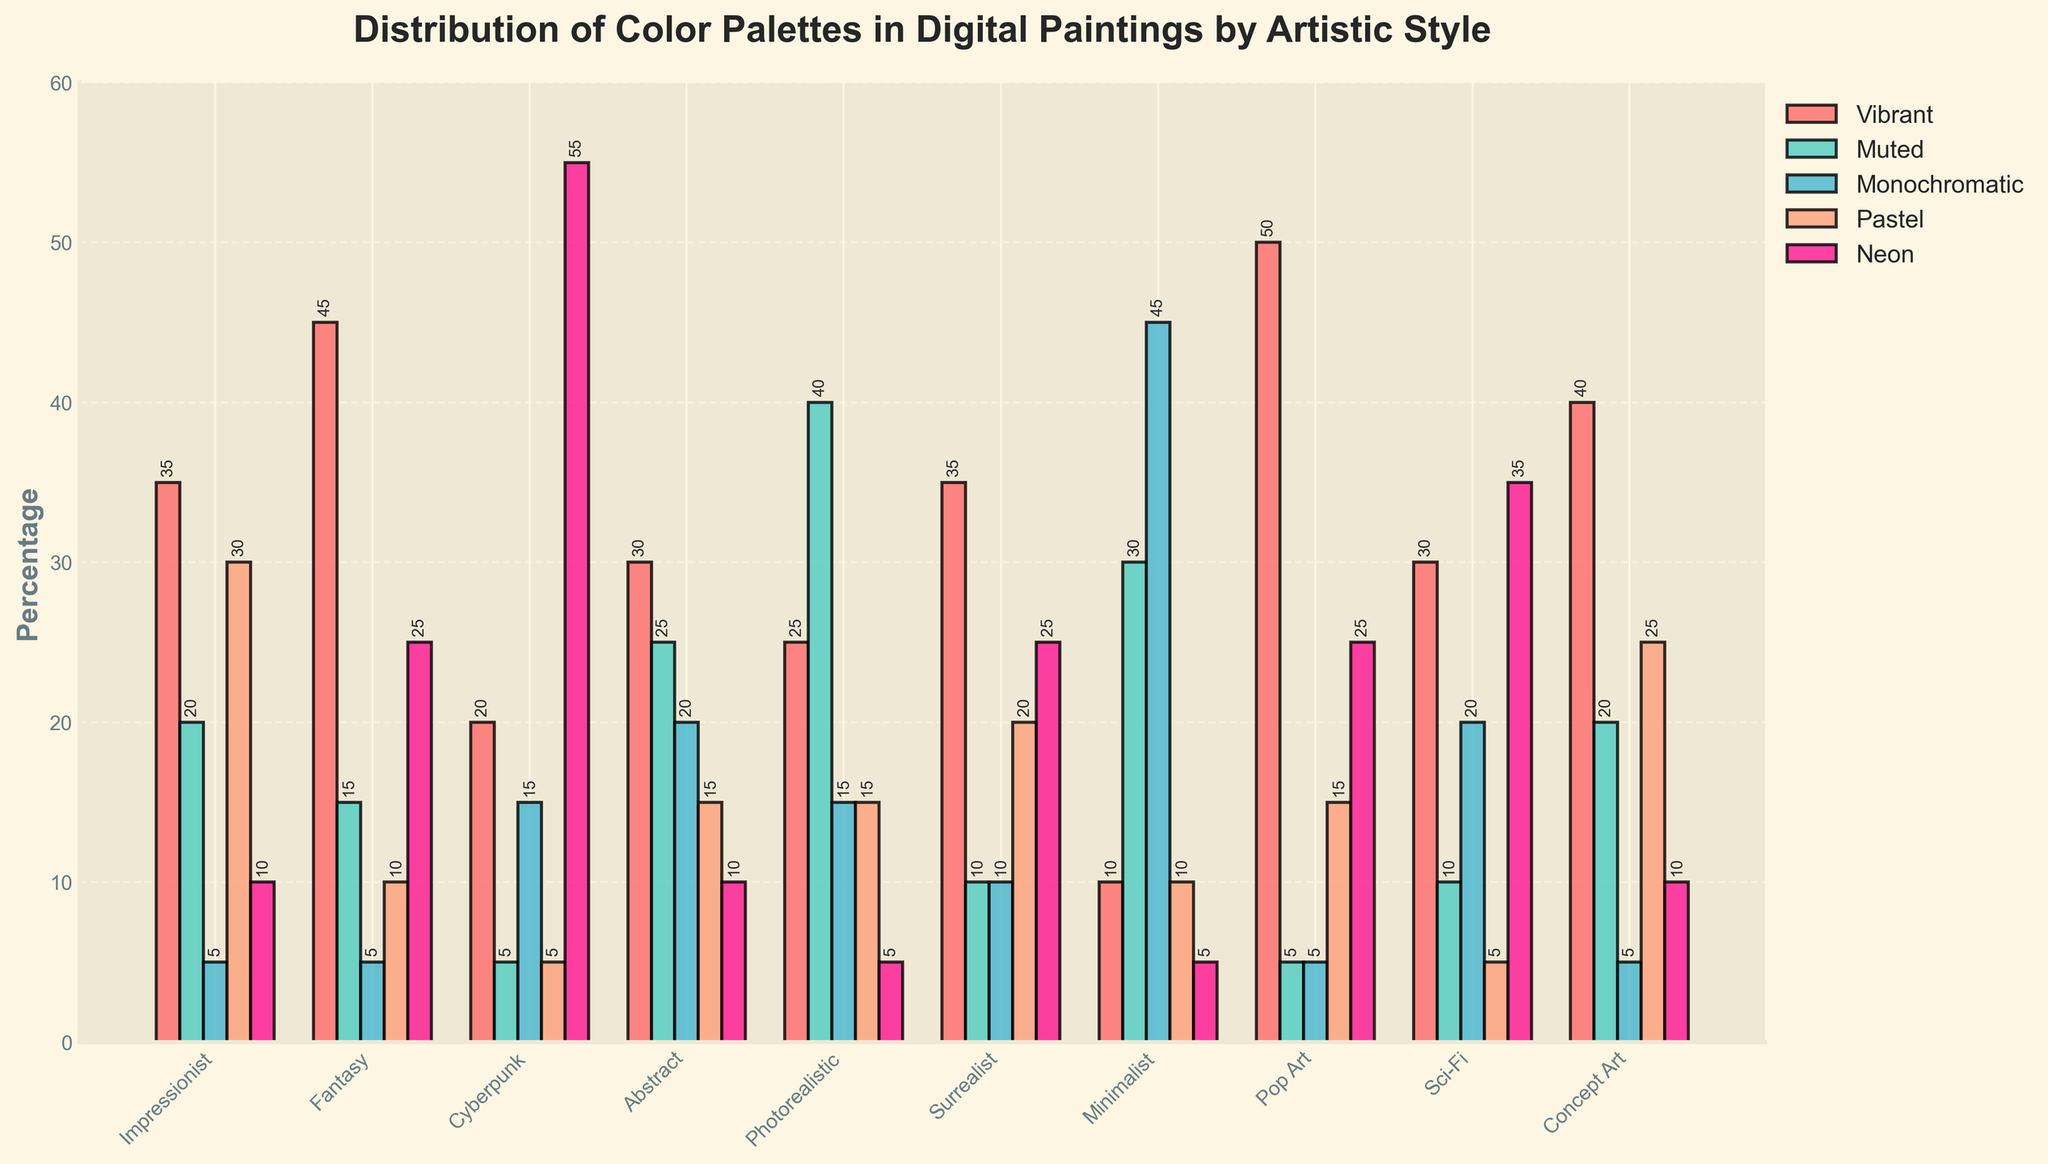Which artistic style has the highest percentage of Vibrant color palette usage? By visually identifying the tallest bar in the Vibrant color palette group, Pop Art is found to have the highest percentage.
Answer: Pop Art Which artistic style utilizes Neon color palette most frequently? By comparing the heights of the bars in the Neon category, Cyberpunk has the tallest bar indicating the highest usage.
Answer: Cyberpunk Which artistic style features the least usage of Monochromatic palette? The shortest bar in the Monochromatic category corresponds to Fantasy and Pop Art, which both have a 5% usage.
Answer: Fantasy and Pop Art What is the difference in the usage of Pastel palette between Impressionist and Abstract styles? Impressionist style has 30% and Abstract has 15% usage of Pastel palette. The difference is calculated as 30 - 15.
Answer: 15% Which artistic style has a balanced distribution across all color palettes? By visually assessing the height uniformity of bars across categories, Abstract appears to have a more balanced distribution.
Answer: Abstract Which artistic style predominantly uses the Muted color palette over Monochromatic? Comparing the heights of the Muted and Monochromatic bars for each style, Photorealistic shows a significantly higher percentage in Muted (40%) over Monochromatic (15%).
Answer: Photorealistic Which two artistic styles have equal percentages for the Monochromatic color palette? Comparing the Monochromatic bars, Impressionist and Fantasy both have a 5% usage.
Answer: Impressionist and Fantasy Which color palette is most commonly used in Concept Art? Identifying the tallest bar in the Concept Art style, the Vibrant palette is the most commonly used with 40%.
Answer: Vibrant For the Surrealist style, what is the combined percentage usage of the Pastel and Neon palettes? By summing the given percentages: Pastel (20%) + Neon (25%) results in a total of 45%.
Answer: 45% How much more is the Vibrant palette used in Fantasy compared to Cyberpunk? Subtracting the percentages: Fantasy (45%) - Cyberpunk (20%) results in a difference of 25%.
Answer: 25% 